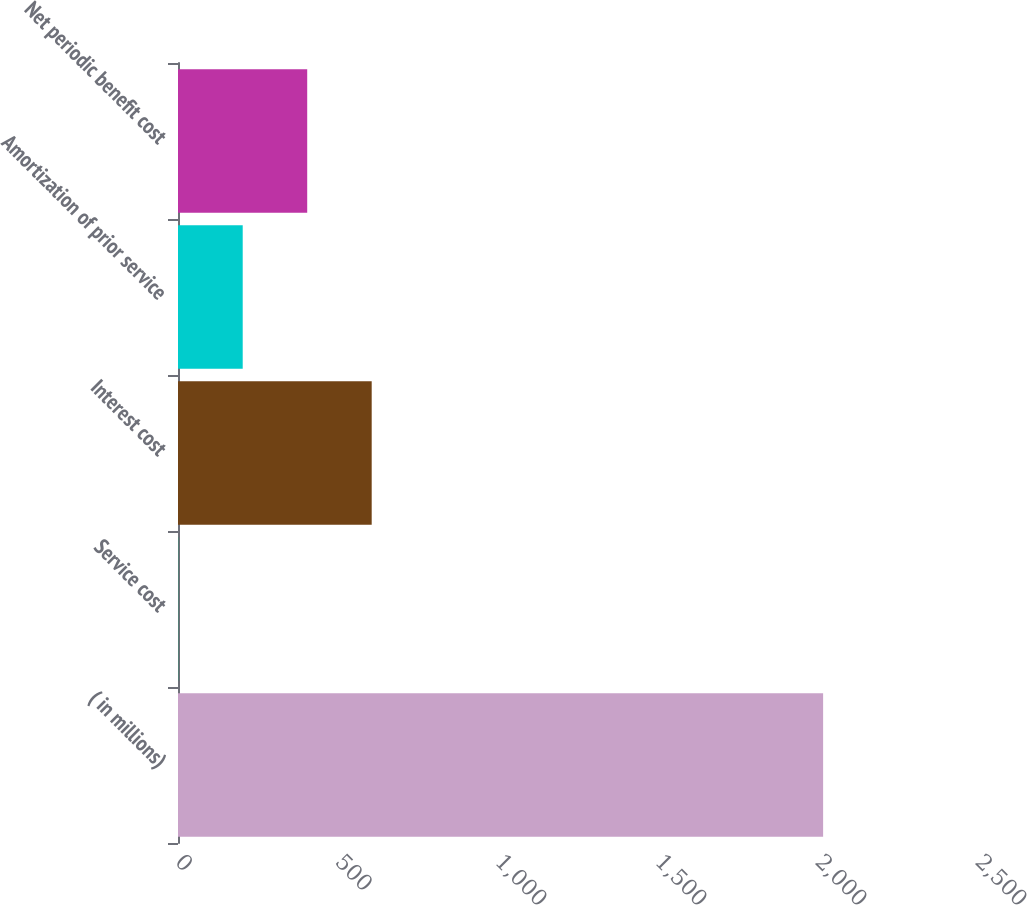Convert chart to OTSL. <chart><loc_0><loc_0><loc_500><loc_500><bar_chart><fcel>( in millions)<fcel>Service cost<fcel>Interest cost<fcel>Amortization of prior service<fcel>Net periodic benefit cost<nl><fcel>2016<fcel>0.7<fcel>605.29<fcel>202.23<fcel>403.76<nl></chart> 